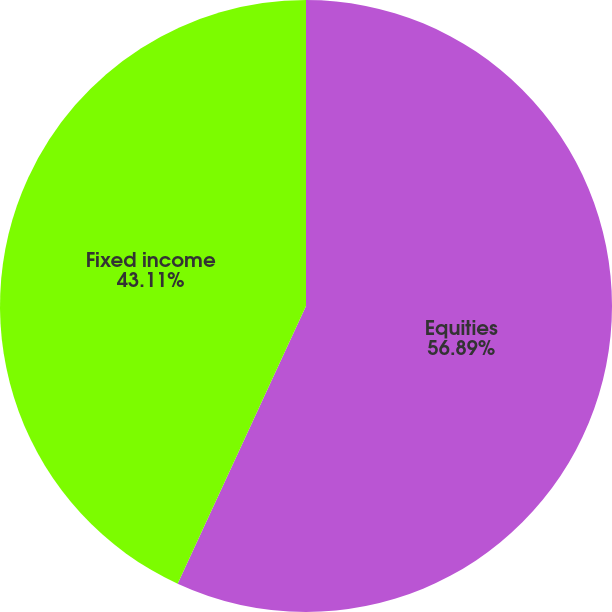Convert chart. <chart><loc_0><loc_0><loc_500><loc_500><pie_chart><fcel>Equities<fcel>Fixed income<nl><fcel>56.89%<fcel>43.11%<nl></chart> 